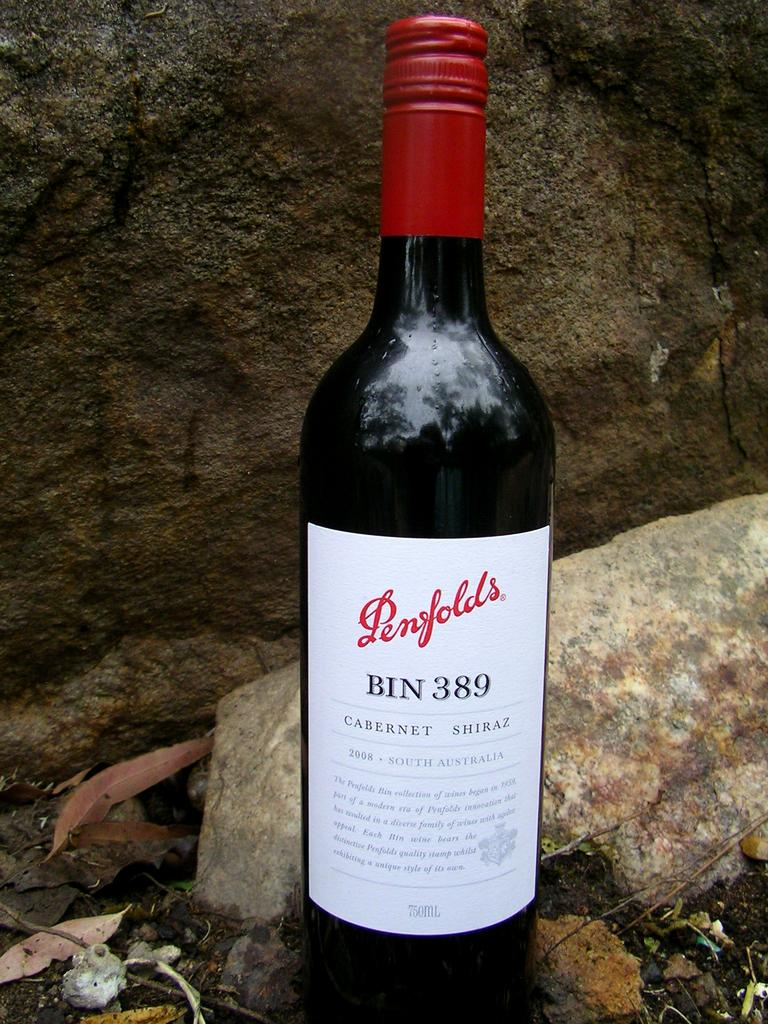<image>
Share a concise interpretation of the image provided. a wine bottle that has penfolds written on it 